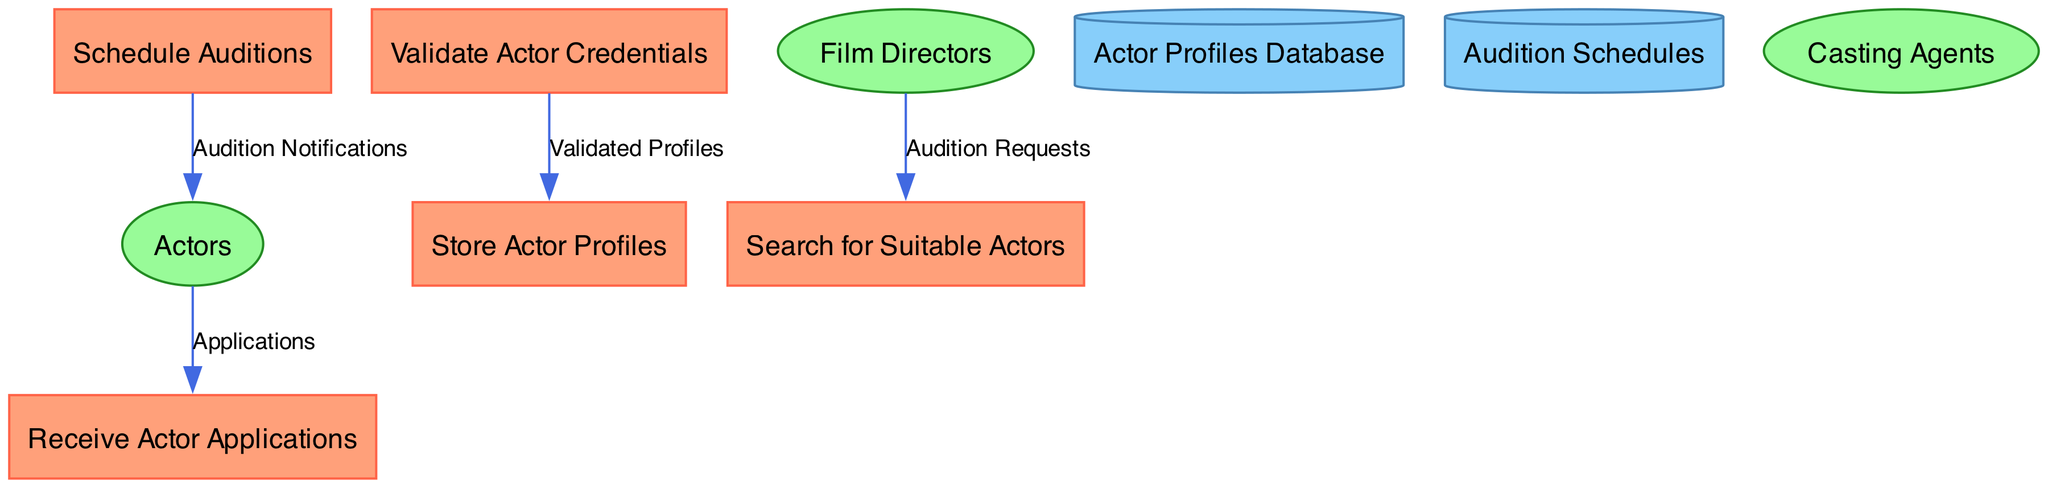What process receives actor applications? The diagram shows an arrow labeled "Applications" flowing from the "Actors" entity to the "Receive Actor Applications" process, indicating that it is responsible for collecting actor applications.
Answer: Receive Actor Applications How many data stores are there? The diagram lists two data stores: "Actor Profiles Database" and "Audition Schedules." This count is determined by simply counting the distinct store nodes present in the diagram.
Answer: 2 What type of data flows from "Validate Actor Credentials" to "Store Actor Profiles"? The connection between "Validate Actor Credentials" and "Store Actor Profiles" is labeled "Validated Profiles," which indicates the type of data that is passed along that flow.
Answer: Validated Profiles Who requests actors for auditions? The arrow pointing from "Film Directors" to "Search for Suitable Actors" shows that the film directors are the entities initiating the request for actors required for auditions.
Answer: Film Directors What is the purpose of the "Audition Notifications"? The "Audition Notifications" data flow goes from "Schedule Auditions" to "Actors," which informs actors about their audition schedules, serving the purpose of notifying them.
Answer: Notifications What is the relationship between "Receive Actor Applications" and "Validate Actor Credentials"? The process "Receive Actor Applications" feeds the subsequent process "Validate Actor Credentials" with data, indicating that once applications are received, they are validated next.
Answer: Sequential What kind of information is stored in the "Actor Profiles Database"? The description of the data store indicates it contains detailed information about actors, thus giving insight into the type of data that is kept there.
Answer: Detailed information about actors What process searches for actors? The diagram clearly indicates that the process labeled "Search for Suitable Actors" is responsible for finding actors based on specific criteria, thus pointing towards its functionality.
Answer: Search for Suitable Actors What type of entity are "Actors"? In the contextual description, "Actors" are identified as individuals submitting their applications and attending auditions, which characterizes the type of external entity they represent in the diagram.
Answer: Individuals submitting applications What is indicated by the data flow "Applications"? The "Applications" data flow from "Actors" to "Receive Actor Applications" signifies the submission of actors' profiles and applications, indicating the action of application submission in the system's workflow.
Answer: Actors submit their profiles and applications 